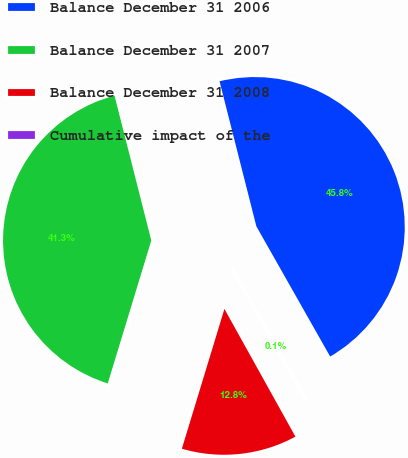Convert chart. <chart><loc_0><loc_0><loc_500><loc_500><pie_chart><fcel>Balance December 31 2006<fcel>Balance December 31 2007<fcel>Balance December 31 2008<fcel>Cumulative impact of the<nl><fcel>45.75%<fcel>41.34%<fcel>12.78%<fcel>0.13%<nl></chart> 